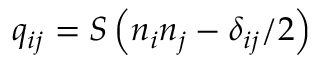Convert formula to latex. <formula><loc_0><loc_0><loc_500><loc_500>q _ { i j } = S \left ( { n } _ { i } n _ { j } - \delta _ { i j } / 2 \right )</formula> 